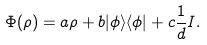Convert formula to latex. <formula><loc_0><loc_0><loc_500><loc_500>\Phi ( \rho ) = a \rho + b | \phi \rangle \langle \phi | + c \frac { 1 } { d } I .</formula> 